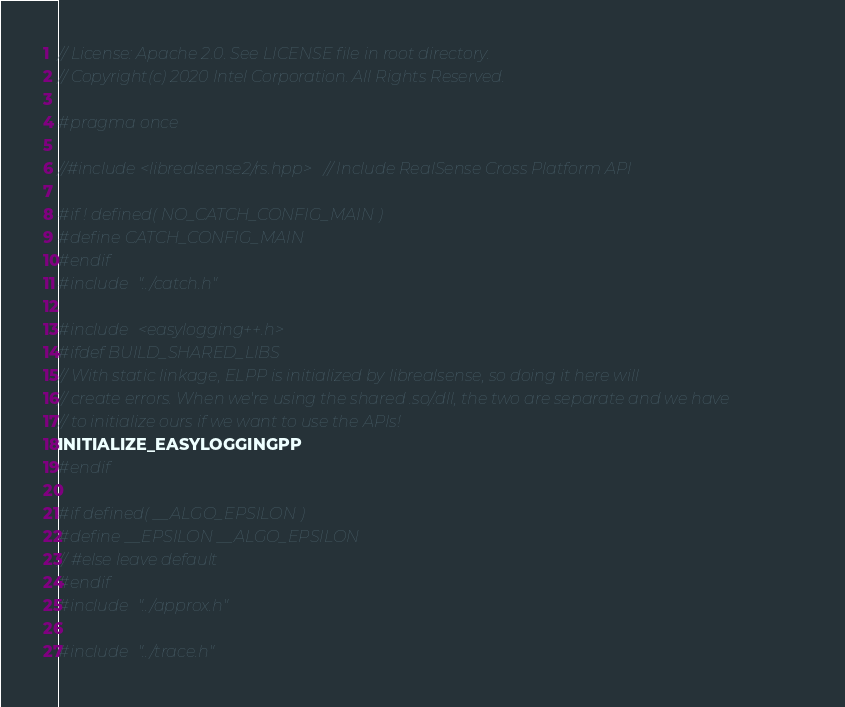<code> <loc_0><loc_0><loc_500><loc_500><_C_>// License: Apache 2.0. See LICENSE file in root directory.
// Copyright(c) 2020 Intel Corporation. All Rights Reserved.

#pragma once

//#include <librealsense2/rs.hpp>   // Include RealSense Cross Platform API

#if ! defined( NO_CATCH_CONFIG_MAIN )
#define CATCH_CONFIG_MAIN
#endif
#include "../catch.h"

#include <easylogging++.h>
#ifdef BUILD_SHARED_LIBS
// With static linkage, ELPP is initialized by librealsense, so doing it here will
// create errors. When we're using the shared .so/.dll, the two are separate and we have
// to initialize ours if we want to use the APIs!
INITIALIZE_EASYLOGGINGPP
#endif

#if defined( __ALGO_EPSILON )
#define __EPSILON __ALGO_EPSILON
// #else leave default
#endif
#include "../approx.h"

#include "../trace.h"
</code> 